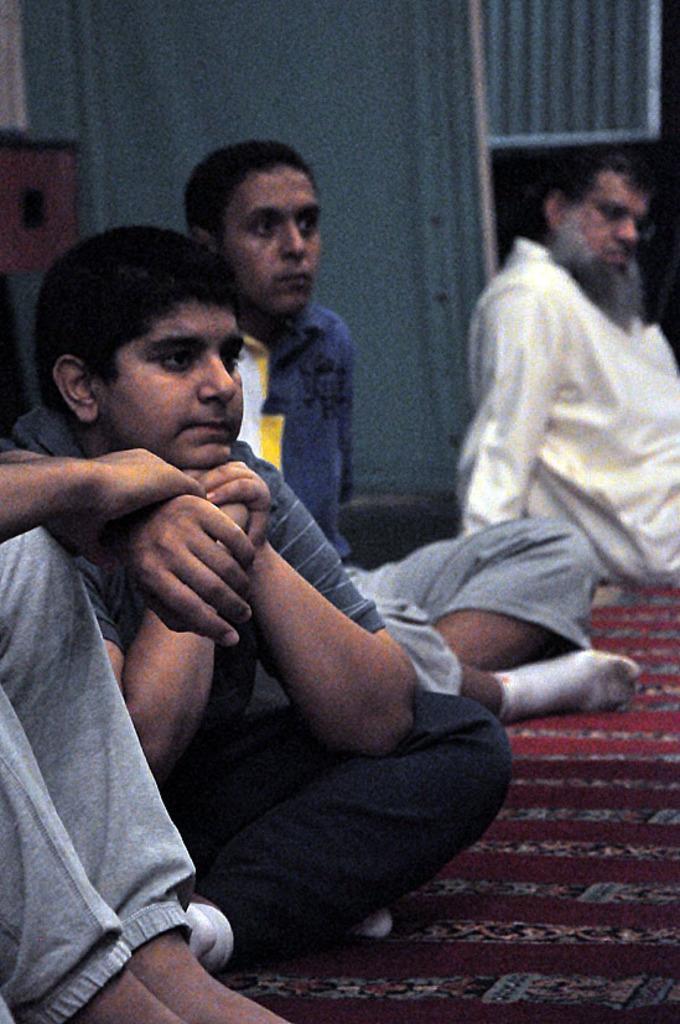Describe this image in one or two sentences. In this image I see 3 persons who are sitting and I see another person's legs and hands over here and I see the red color carpet. In the background I see the blue color thing over here. 